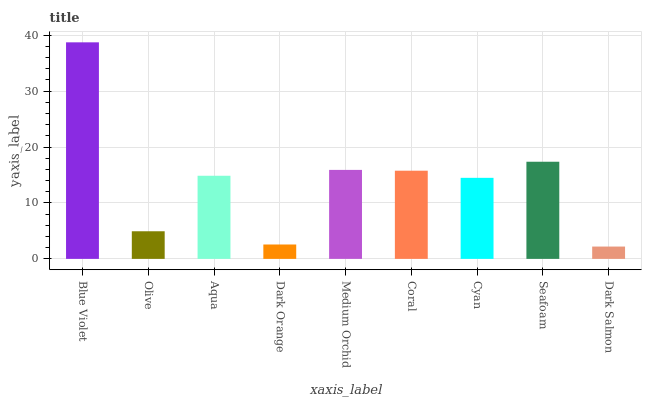Is Dark Salmon the minimum?
Answer yes or no. Yes. Is Blue Violet the maximum?
Answer yes or no. Yes. Is Olive the minimum?
Answer yes or no. No. Is Olive the maximum?
Answer yes or no. No. Is Blue Violet greater than Olive?
Answer yes or no. Yes. Is Olive less than Blue Violet?
Answer yes or no. Yes. Is Olive greater than Blue Violet?
Answer yes or no. No. Is Blue Violet less than Olive?
Answer yes or no. No. Is Aqua the high median?
Answer yes or no. Yes. Is Aqua the low median?
Answer yes or no. Yes. Is Olive the high median?
Answer yes or no. No. Is Dark Salmon the low median?
Answer yes or no. No. 